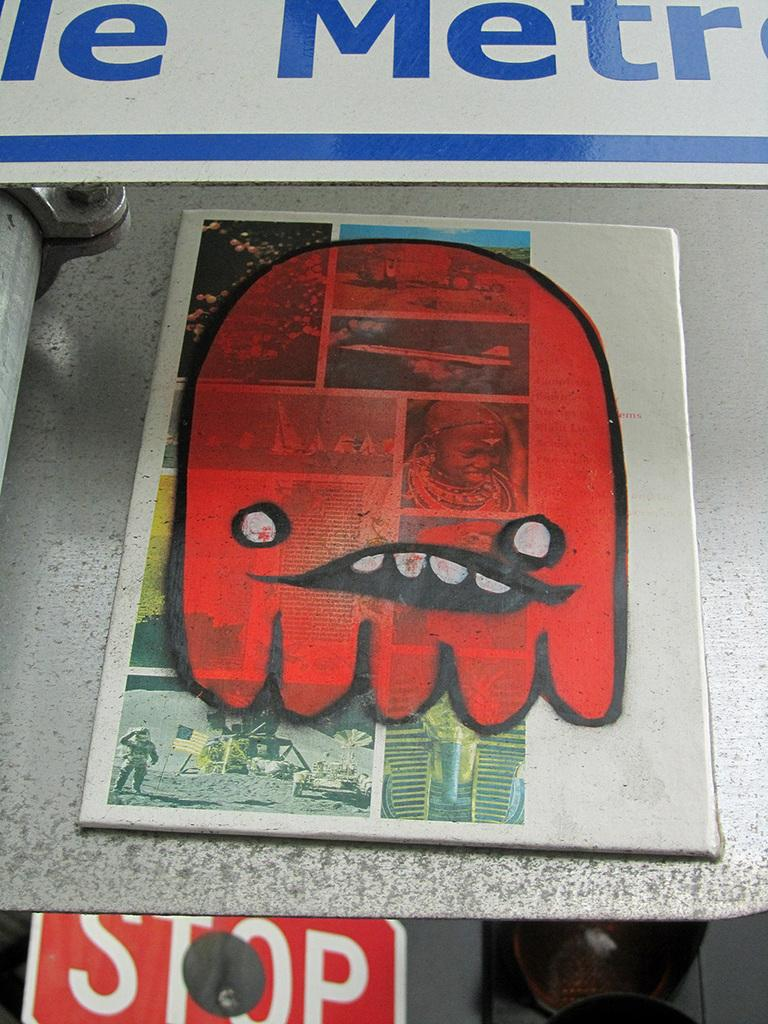<image>
Offer a succinct explanation of the picture presented. A stop sign is under a sign with a red blob face. 